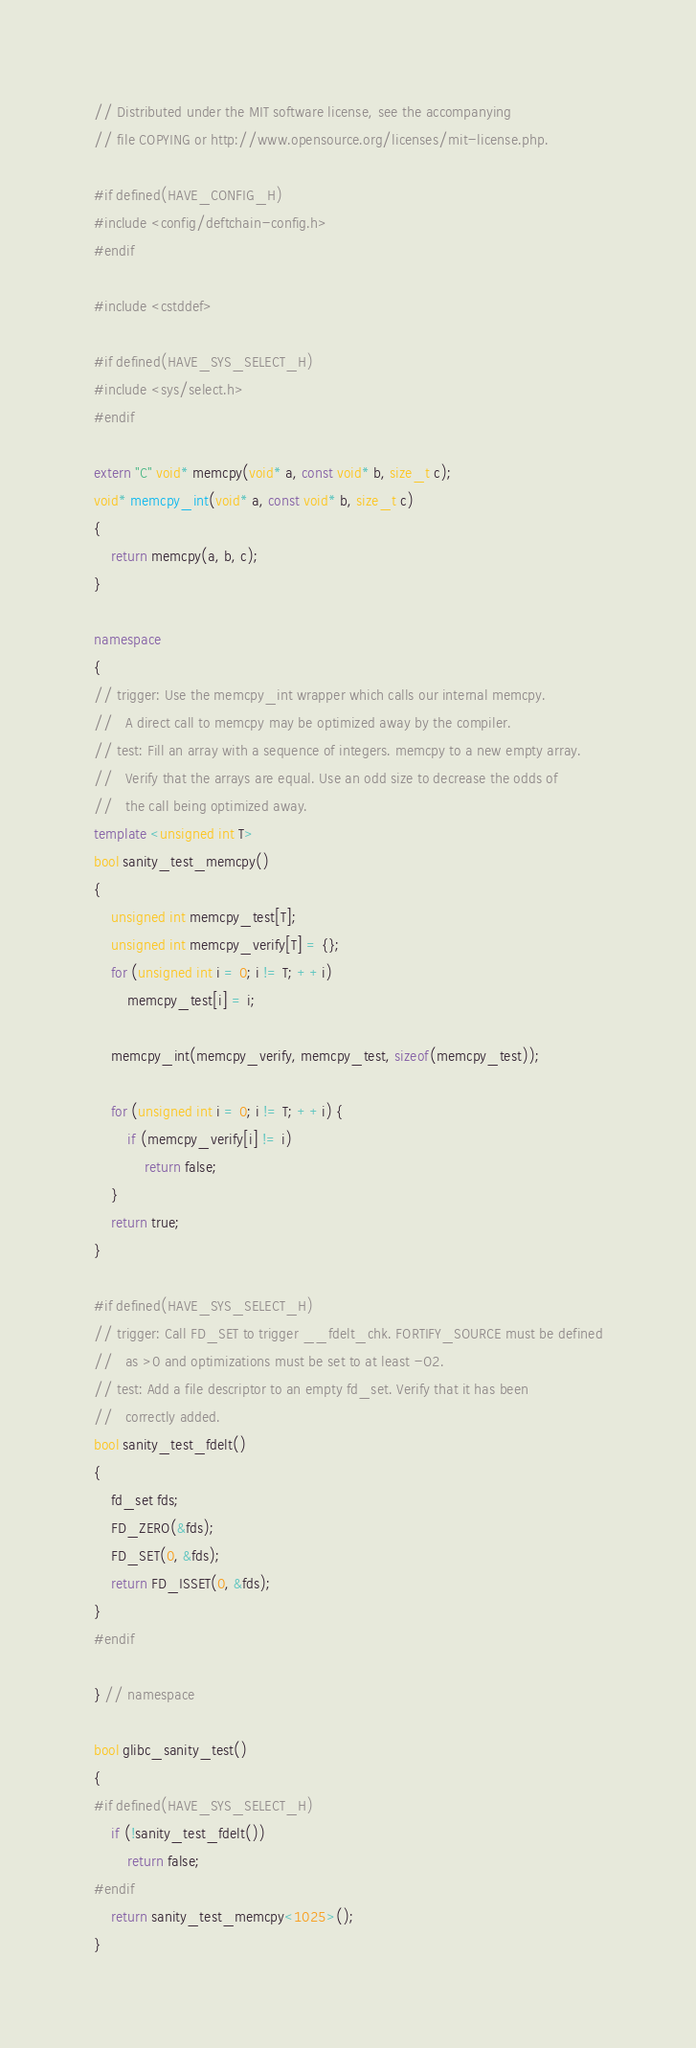Convert code to text. <code><loc_0><loc_0><loc_500><loc_500><_C++_>// Distributed under the MIT software license, see the accompanying
// file COPYING or http://www.opensource.org/licenses/mit-license.php.

#if defined(HAVE_CONFIG_H)
#include <config/deftchain-config.h>
#endif

#include <cstddef>

#if defined(HAVE_SYS_SELECT_H)
#include <sys/select.h>
#endif

extern "C" void* memcpy(void* a, const void* b, size_t c);
void* memcpy_int(void* a, const void* b, size_t c)
{
    return memcpy(a, b, c);
}

namespace
{
// trigger: Use the memcpy_int wrapper which calls our internal memcpy.
//   A direct call to memcpy may be optimized away by the compiler.
// test: Fill an array with a sequence of integers. memcpy to a new empty array.
//   Verify that the arrays are equal. Use an odd size to decrease the odds of
//   the call being optimized away.
template <unsigned int T>
bool sanity_test_memcpy()
{
    unsigned int memcpy_test[T];
    unsigned int memcpy_verify[T] = {};
    for (unsigned int i = 0; i != T; ++i)
        memcpy_test[i] = i;

    memcpy_int(memcpy_verify, memcpy_test, sizeof(memcpy_test));

    for (unsigned int i = 0; i != T; ++i) {
        if (memcpy_verify[i] != i)
            return false;
    }
    return true;
}

#if defined(HAVE_SYS_SELECT_H)
// trigger: Call FD_SET to trigger __fdelt_chk. FORTIFY_SOURCE must be defined
//   as >0 and optimizations must be set to at least -O2.
// test: Add a file descriptor to an empty fd_set. Verify that it has been
//   correctly added.
bool sanity_test_fdelt()
{
    fd_set fds;
    FD_ZERO(&fds);
    FD_SET(0, &fds);
    return FD_ISSET(0, &fds);
}
#endif

} // namespace

bool glibc_sanity_test()
{
#if defined(HAVE_SYS_SELECT_H)
    if (!sanity_test_fdelt())
        return false;
#endif
    return sanity_test_memcpy<1025>();
}

</code> 